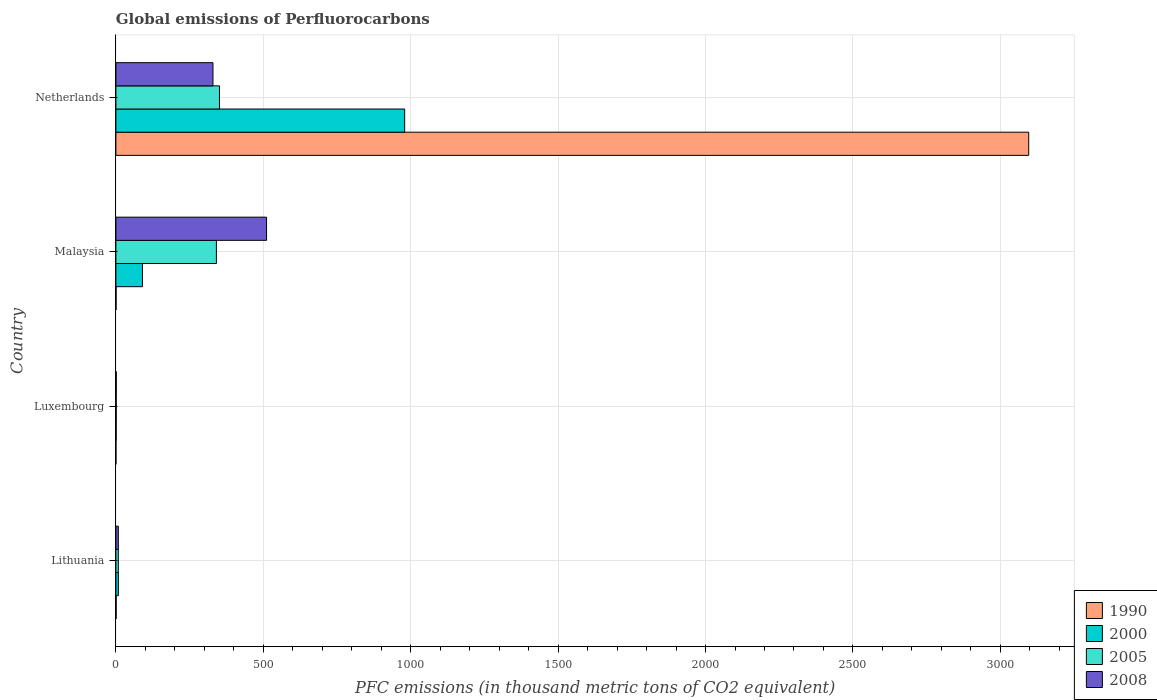How many different coloured bars are there?
Your answer should be very brief. 4. How many groups of bars are there?
Offer a terse response. 4. Are the number of bars on each tick of the Y-axis equal?
Your answer should be very brief. Yes. How many bars are there on the 2nd tick from the top?
Provide a short and direct response. 4. What is the label of the 1st group of bars from the top?
Your answer should be compact. Netherlands. Across all countries, what is the maximum global emissions of Perfluorocarbons in 2000?
Keep it short and to the point. 979.5. In which country was the global emissions of Perfluorocarbons in 2000 minimum?
Keep it short and to the point. Luxembourg. What is the total global emissions of Perfluorocarbons in 1990 in the graph?
Provide a short and direct response. 3097.8. What is the difference between the global emissions of Perfluorocarbons in 2008 in Lithuania and that in Malaysia?
Your answer should be compact. -502.8. What is the difference between the global emissions of Perfluorocarbons in 2000 in Malaysia and the global emissions of Perfluorocarbons in 2008 in Netherlands?
Keep it short and to the point. -239.1. What is the average global emissions of Perfluorocarbons in 2000 per country?
Your response must be concise. 269.75. What is the difference between the global emissions of Perfluorocarbons in 2008 and global emissions of Perfluorocarbons in 1990 in Malaysia?
Provide a short and direct response. 510.4. What is the ratio of the global emissions of Perfluorocarbons in 2008 in Lithuania to that in Malaysia?
Ensure brevity in your answer.  0.02. What is the difference between the highest and the second highest global emissions of Perfluorocarbons in 2000?
Your answer should be compact. 889.4. What is the difference between the highest and the lowest global emissions of Perfluorocarbons in 2000?
Keep it short and to the point. 978.5. In how many countries, is the global emissions of Perfluorocarbons in 2000 greater than the average global emissions of Perfluorocarbons in 2000 taken over all countries?
Ensure brevity in your answer.  1. Is the sum of the global emissions of Perfluorocarbons in 1990 in Lithuania and Malaysia greater than the maximum global emissions of Perfluorocarbons in 2008 across all countries?
Ensure brevity in your answer.  No. What does the 2nd bar from the top in Luxembourg represents?
Offer a very short reply. 2005. Is it the case that in every country, the sum of the global emissions of Perfluorocarbons in 2000 and global emissions of Perfluorocarbons in 1990 is greater than the global emissions of Perfluorocarbons in 2008?
Offer a very short reply. No. How many bars are there?
Provide a short and direct response. 16. Are all the bars in the graph horizontal?
Your response must be concise. Yes. How many countries are there in the graph?
Your answer should be very brief. 4. What is the difference between two consecutive major ticks on the X-axis?
Offer a very short reply. 500. Are the values on the major ticks of X-axis written in scientific E-notation?
Your response must be concise. No. Does the graph contain any zero values?
Your answer should be very brief. No. What is the title of the graph?
Provide a succinct answer. Global emissions of Perfluorocarbons. Does "1978" appear as one of the legend labels in the graph?
Your answer should be compact. No. What is the label or title of the X-axis?
Give a very brief answer. PFC emissions (in thousand metric tons of CO2 equivalent). What is the PFC emissions (in thousand metric tons of CO2 equivalent) of 1990 in Lithuania?
Offer a very short reply. 0.9. What is the PFC emissions (in thousand metric tons of CO2 equivalent) in 2005 in Lithuania?
Your answer should be very brief. 8.2. What is the PFC emissions (in thousand metric tons of CO2 equivalent) in 1990 in Luxembourg?
Offer a terse response. 0.1. What is the PFC emissions (in thousand metric tons of CO2 equivalent) in 2005 in Luxembourg?
Your answer should be very brief. 1.1. What is the PFC emissions (in thousand metric tons of CO2 equivalent) in 2008 in Luxembourg?
Your response must be concise. 1.2. What is the PFC emissions (in thousand metric tons of CO2 equivalent) in 1990 in Malaysia?
Provide a short and direct response. 0.6. What is the PFC emissions (in thousand metric tons of CO2 equivalent) in 2000 in Malaysia?
Keep it short and to the point. 90.1. What is the PFC emissions (in thousand metric tons of CO2 equivalent) of 2005 in Malaysia?
Keep it short and to the point. 340.9. What is the PFC emissions (in thousand metric tons of CO2 equivalent) in 2008 in Malaysia?
Ensure brevity in your answer.  511. What is the PFC emissions (in thousand metric tons of CO2 equivalent) of 1990 in Netherlands?
Provide a succinct answer. 3096.2. What is the PFC emissions (in thousand metric tons of CO2 equivalent) in 2000 in Netherlands?
Ensure brevity in your answer.  979.5. What is the PFC emissions (in thousand metric tons of CO2 equivalent) in 2005 in Netherlands?
Offer a very short reply. 351.4. What is the PFC emissions (in thousand metric tons of CO2 equivalent) in 2008 in Netherlands?
Provide a succinct answer. 329.2. Across all countries, what is the maximum PFC emissions (in thousand metric tons of CO2 equivalent) in 1990?
Your answer should be very brief. 3096.2. Across all countries, what is the maximum PFC emissions (in thousand metric tons of CO2 equivalent) in 2000?
Give a very brief answer. 979.5. Across all countries, what is the maximum PFC emissions (in thousand metric tons of CO2 equivalent) of 2005?
Your answer should be very brief. 351.4. Across all countries, what is the maximum PFC emissions (in thousand metric tons of CO2 equivalent) in 2008?
Offer a very short reply. 511. Across all countries, what is the minimum PFC emissions (in thousand metric tons of CO2 equivalent) of 2000?
Offer a very short reply. 1. What is the total PFC emissions (in thousand metric tons of CO2 equivalent) of 1990 in the graph?
Ensure brevity in your answer.  3097.8. What is the total PFC emissions (in thousand metric tons of CO2 equivalent) of 2000 in the graph?
Ensure brevity in your answer.  1079. What is the total PFC emissions (in thousand metric tons of CO2 equivalent) in 2005 in the graph?
Provide a succinct answer. 701.6. What is the total PFC emissions (in thousand metric tons of CO2 equivalent) in 2008 in the graph?
Your answer should be very brief. 849.6. What is the difference between the PFC emissions (in thousand metric tons of CO2 equivalent) in 2000 in Lithuania and that in Malaysia?
Your answer should be very brief. -81.7. What is the difference between the PFC emissions (in thousand metric tons of CO2 equivalent) in 2005 in Lithuania and that in Malaysia?
Give a very brief answer. -332.7. What is the difference between the PFC emissions (in thousand metric tons of CO2 equivalent) of 2008 in Lithuania and that in Malaysia?
Your response must be concise. -502.8. What is the difference between the PFC emissions (in thousand metric tons of CO2 equivalent) of 1990 in Lithuania and that in Netherlands?
Your answer should be compact. -3095.3. What is the difference between the PFC emissions (in thousand metric tons of CO2 equivalent) of 2000 in Lithuania and that in Netherlands?
Make the answer very short. -971.1. What is the difference between the PFC emissions (in thousand metric tons of CO2 equivalent) in 2005 in Lithuania and that in Netherlands?
Offer a very short reply. -343.2. What is the difference between the PFC emissions (in thousand metric tons of CO2 equivalent) in 2008 in Lithuania and that in Netherlands?
Your answer should be very brief. -321. What is the difference between the PFC emissions (in thousand metric tons of CO2 equivalent) in 1990 in Luxembourg and that in Malaysia?
Your response must be concise. -0.5. What is the difference between the PFC emissions (in thousand metric tons of CO2 equivalent) in 2000 in Luxembourg and that in Malaysia?
Give a very brief answer. -89.1. What is the difference between the PFC emissions (in thousand metric tons of CO2 equivalent) in 2005 in Luxembourg and that in Malaysia?
Make the answer very short. -339.8. What is the difference between the PFC emissions (in thousand metric tons of CO2 equivalent) in 2008 in Luxembourg and that in Malaysia?
Your answer should be very brief. -509.8. What is the difference between the PFC emissions (in thousand metric tons of CO2 equivalent) of 1990 in Luxembourg and that in Netherlands?
Give a very brief answer. -3096.1. What is the difference between the PFC emissions (in thousand metric tons of CO2 equivalent) of 2000 in Luxembourg and that in Netherlands?
Your answer should be compact. -978.5. What is the difference between the PFC emissions (in thousand metric tons of CO2 equivalent) in 2005 in Luxembourg and that in Netherlands?
Offer a very short reply. -350.3. What is the difference between the PFC emissions (in thousand metric tons of CO2 equivalent) in 2008 in Luxembourg and that in Netherlands?
Offer a very short reply. -328. What is the difference between the PFC emissions (in thousand metric tons of CO2 equivalent) in 1990 in Malaysia and that in Netherlands?
Your response must be concise. -3095.6. What is the difference between the PFC emissions (in thousand metric tons of CO2 equivalent) in 2000 in Malaysia and that in Netherlands?
Offer a very short reply. -889.4. What is the difference between the PFC emissions (in thousand metric tons of CO2 equivalent) of 2005 in Malaysia and that in Netherlands?
Your response must be concise. -10.5. What is the difference between the PFC emissions (in thousand metric tons of CO2 equivalent) in 2008 in Malaysia and that in Netherlands?
Your answer should be compact. 181.8. What is the difference between the PFC emissions (in thousand metric tons of CO2 equivalent) of 1990 in Lithuania and the PFC emissions (in thousand metric tons of CO2 equivalent) of 2000 in Luxembourg?
Provide a short and direct response. -0.1. What is the difference between the PFC emissions (in thousand metric tons of CO2 equivalent) in 1990 in Lithuania and the PFC emissions (in thousand metric tons of CO2 equivalent) in 2005 in Luxembourg?
Offer a terse response. -0.2. What is the difference between the PFC emissions (in thousand metric tons of CO2 equivalent) in 1990 in Lithuania and the PFC emissions (in thousand metric tons of CO2 equivalent) in 2008 in Luxembourg?
Your answer should be very brief. -0.3. What is the difference between the PFC emissions (in thousand metric tons of CO2 equivalent) of 2000 in Lithuania and the PFC emissions (in thousand metric tons of CO2 equivalent) of 2008 in Luxembourg?
Offer a very short reply. 7.2. What is the difference between the PFC emissions (in thousand metric tons of CO2 equivalent) in 2005 in Lithuania and the PFC emissions (in thousand metric tons of CO2 equivalent) in 2008 in Luxembourg?
Keep it short and to the point. 7. What is the difference between the PFC emissions (in thousand metric tons of CO2 equivalent) in 1990 in Lithuania and the PFC emissions (in thousand metric tons of CO2 equivalent) in 2000 in Malaysia?
Ensure brevity in your answer.  -89.2. What is the difference between the PFC emissions (in thousand metric tons of CO2 equivalent) of 1990 in Lithuania and the PFC emissions (in thousand metric tons of CO2 equivalent) of 2005 in Malaysia?
Ensure brevity in your answer.  -340. What is the difference between the PFC emissions (in thousand metric tons of CO2 equivalent) in 1990 in Lithuania and the PFC emissions (in thousand metric tons of CO2 equivalent) in 2008 in Malaysia?
Give a very brief answer. -510.1. What is the difference between the PFC emissions (in thousand metric tons of CO2 equivalent) of 2000 in Lithuania and the PFC emissions (in thousand metric tons of CO2 equivalent) of 2005 in Malaysia?
Keep it short and to the point. -332.5. What is the difference between the PFC emissions (in thousand metric tons of CO2 equivalent) in 2000 in Lithuania and the PFC emissions (in thousand metric tons of CO2 equivalent) in 2008 in Malaysia?
Your answer should be very brief. -502.6. What is the difference between the PFC emissions (in thousand metric tons of CO2 equivalent) of 2005 in Lithuania and the PFC emissions (in thousand metric tons of CO2 equivalent) of 2008 in Malaysia?
Give a very brief answer. -502.8. What is the difference between the PFC emissions (in thousand metric tons of CO2 equivalent) of 1990 in Lithuania and the PFC emissions (in thousand metric tons of CO2 equivalent) of 2000 in Netherlands?
Your response must be concise. -978.6. What is the difference between the PFC emissions (in thousand metric tons of CO2 equivalent) of 1990 in Lithuania and the PFC emissions (in thousand metric tons of CO2 equivalent) of 2005 in Netherlands?
Keep it short and to the point. -350.5. What is the difference between the PFC emissions (in thousand metric tons of CO2 equivalent) of 1990 in Lithuania and the PFC emissions (in thousand metric tons of CO2 equivalent) of 2008 in Netherlands?
Make the answer very short. -328.3. What is the difference between the PFC emissions (in thousand metric tons of CO2 equivalent) in 2000 in Lithuania and the PFC emissions (in thousand metric tons of CO2 equivalent) in 2005 in Netherlands?
Your answer should be very brief. -343. What is the difference between the PFC emissions (in thousand metric tons of CO2 equivalent) of 2000 in Lithuania and the PFC emissions (in thousand metric tons of CO2 equivalent) of 2008 in Netherlands?
Your answer should be compact. -320.8. What is the difference between the PFC emissions (in thousand metric tons of CO2 equivalent) in 2005 in Lithuania and the PFC emissions (in thousand metric tons of CO2 equivalent) in 2008 in Netherlands?
Provide a short and direct response. -321. What is the difference between the PFC emissions (in thousand metric tons of CO2 equivalent) of 1990 in Luxembourg and the PFC emissions (in thousand metric tons of CO2 equivalent) of 2000 in Malaysia?
Your response must be concise. -90. What is the difference between the PFC emissions (in thousand metric tons of CO2 equivalent) of 1990 in Luxembourg and the PFC emissions (in thousand metric tons of CO2 equivalent) of 2005 in Malaysia?
Make the answer very short. -340.8. What is the difference between the PFC emissions (in thousand metric tons of CO2 equivalent) of 1990 in Luxembourg and the PFC emissions (in thousand metric tons of CO2 equivalent) of 2008 in Malaysia?
Provide a succinct answer. -510.9. What is the difference between the PFC emissions (in thousand metric tons of CO2 equivalent) in 2000 in Luxembourg and the PFC emissions (in thousand metric tons of CO2 equivalent) in 2005 in Malaysia?
Keep it short and to the point. -339.9. What is the difference between the PFC emissions (in thousand metric tons of CO2 equivalent) of 2000 in Luxembourg and the PFC emissions (in thousand metric tons of CO2 equivalent) of 2008 in Malaysia?
Your answer should be very brief. -510. What is the difference between the PFC emissions (in thousand metric tons of CO2 equivalent) in 2005 in Luxembourg and the PFC emissions (in thousand metric tons of CO2 equivalent) in 2008 in Malaysia?
Ensure brevity in your answer.  -509.9. What is the difference between the PFC emissions (in thousand metric tons of CO2 equivalent) of 1990 in Luxembourg and the PFC emissions (in thousand metric tons of CO2 equivalent) of 2000 in Netherlands?
Your answer should be very brief. -979.4. What is the difference between the PFC emissions (in thousand metric tons of CO2 equivalent) in 1990 in Luxembourg and the PFC emissions (in thousand metric tons of CO2 equivalent) in 2005 in Netherlands?
Give a very brief answer. -351.3. What is the difference between the PFC emissions (in thousand metric tons of CO2 equivalent) of 1990 in Luxembourg and the PFC emissions (in thousand metric tons of CO2 equivalent) of 2008 in Netherlands?
Make the answer very short. -329.1. What is the difference between the PFC emissions (in thousand metric tons of CO2 equivalent) in 2000 in Luxembourg and the PFC emissions (in thousand metric tons of CO2 equivalent) in 2005 in Netherlands?
Provide a succinct answer. -350.4. What is the difference between the PFC emissions (in thousand metric tons of CO2 equivalent) of 2000 in Luxembourg and the PFC emissions (in thousand metric tons of CO2 equivalent) of 2008 in Netherlands?
Offer a very short reply. -328.2. What is the difference between the PFC emissions (in thousand metric tons of CO2 equivalent) in 2005 in Luxembourg and the PFC emissions (in thousand metric tons of CO2 equivalent) in 2008 in Netherlands?
Provide a short and direct response. -328.1. What is the difference between the PFC emissions (in thousand metric tons of CO2 equivalent) of 1990 in Malaysia and the PFC emissions (in thousand metric tons of CO2 equivalent) of 2000 in Netherlands?
Give a very brief answer. -978.9. What is the difference between the PFC emissions (in thousand metric tons of CO2 equivalent) of 1990 in Malaysia and the PFC emissions (in thousand metric tons of CO2 equivalent) of 2005 in Netherlands?
Your answer should be very brief. -350.8. What is the difference between the PFC emissions (in thousand metric tons of CO2 equivalent) of 1990 in Malaysia and the PFC emissions (in thousand metric tons of CO2 equivalent) of 2008 in Netherlands?
Give a very brief answer. -328.6. What is the difference between the PFC emissions (in thousand metric tons of CO2 equivalent) of 2000 in Malaysia and the PFC emissions (in thousand metric tons of CO2 equivalent) of 2005 in Netherlands?
Your answer should be compact. -261.3. What is the difference between the PFC emissions (in thousand metric tons of CO2 equivalent) of 2000 in Malaysia and the PFC emissions (in thousand metric tons of CO2 equivalent) of 2008 in Netherlands?
Keep it short and to the point. -239.1. What is the difference between the PFC emissions (in thousand metric tons of CO2 equivalent) of 2005 in Malaysia and the PFC emissions (in thousand metric tons of CO2 equivalent) of 2008 in Netherlands?
Your answer should be very brief. 11.7. What is the average PFC emissions (in thousand metric tons of CO2 equivalent) in 1990 per country?
Your answer should be very brief. 774.45. What is the average PFC emissions (in thousand metric tons of CO2 equivalent) of 2000 per country?
Offer a terse response. 269.75. What is the average PFC emissions (in thousand metric tons of CO2 equivalent) of 2005 per country?
Provide a short and direct response. 175.4. What is the average PFC emissions (in thousand metric tons of CO2 equivalent) of 2008 per country?
Provide a short and direct response. 212.4. What is the difference between the PFC emissions (in thousand metric tons of CO2 equivalent) of 1990 and PFC emissions (in thousand metric tons of CO2 equivalent) of 2000 in Lithuania?
Provide a succinct answer. -7.5. What is the difference between the PFC emissions (in thousand metric tons of CO2 equivalent) of 1990 and PFC emissions (in thousand metric tons of CO2 equivalent) of 2005 in Lithuania?
Give a very brief answer. -7.3. What is the difference between the PFC emissions (in thousand metric tons of CO2 equivalent) in 2000 and PFC emissions (in thousand metric tons of CO2 equivalent) in 2005 in Lithuania?
Make the answer very short. 0.2. What is the difference between the PFC emissions (in thousand metric tons of CO2 equivalent) in 1990 and PFC emissions (in thousand metric tons of CO2 equivalent) in 2000 in Luxembourg?
Offer a very short reply. -0.9. What is the difference between the PFC emissions (in thousand metric tons of CO2 equivalent) of 1990 and PFC emissions (in thousand metric tons of CO2 equivalent) of 2005 in Luxembourg?
Keep it short and to the point. -1. What is the difference between the PFC emissions (in thousand metric tons of CO2 equivalent) of 1990 and PFC emissions (in thousand metric tons of CO2 equivalent) of 2008 in Luxembourg?
Give a very brief answer. -1.1. What is the difference between the PFC emissions (in thousand metric tons of CO2 equivalent) in 2000 and PFC emissions (in thousand metric tons of CO2 equivalent) in 2005 in Luxembourg?
Make the answer very short. -0.1. What is the difference between the PFC emissions (in thousand metric tons of CO2 equivalent) in 2000 and PFC emissions (in thousand metric tons of CO2 equivalent) in 2008 in Luxembourg?
Give a very brief answer. -0.2. What is the difference between the PFC emissions (in thousand metric tons of CO2 equivalent) of 2005 and PFC emissions (in thousand metric tons of CO2 equivalent) of 2008 in Luxembourg?
Your response must be concise. -0.1. What is the difference between the PFC emissions (in thousand metric tons of CO2 equivalent) in 1990 and PFC emissions (in thousand metric tons of CO2 equivalent) in 2000 in Malaysia?
Provide a short and direct response. -89.5. What is the difference between the PFC emissions (in thousand metric tons of CO2 equivalent) of 1990 and PFC emissions (in thousand metric tons of CO2 equivalent) of 2005 in Malaysia?
Ensure brevity in your answer.  -340.3. What is the difference between the PFC emissions (in thousand metric tons of CO2 equivalent) in 1990 and PFC emissions (in thousand metric tons of CO2 equivalent) in 2008 in Malaysia?
Offer a terse response. -510.4. What is the difference between the PFC emissions (in thousand metric tons of CO2 equivalent) in 2000 and PFC emissions (in thousand metric tons of CO2 equivalent) in 2005 in Malaysia?
Provide a short and direct response. -250.8. What is the difference between the PFC emissions (in thousand metric tons of CO2 equivalent) of 2000 and PFC emissions (in thousand metric tons of CO2 equivalent) of 2008 in Malaysia?
Provide a succinct answer. -420.9. What is the difference between the PFC emissions (in thousand metric tons of CO2 equivalent) in 2005 and PFC emissions (in thousand metric tons of CO2 equivalent) in 2008 in Malaysia?
Provide a short and direct response. -170.1. What is the difference between the PFC emissions (in thousand metric tons of CO2 equivalent) in 1990 and PFC emissions (in thousand metric tons of CO2 equivalent) in 2000 in Netherlands?
Your answer should be very brief. 2116.7. What is the difference between the PFC emissions (in thousand metric tons of CO2 equivalent) in 1990 and PFC emissions (in thousand metric tons of CO2 equivalent) in 2005 in Netherlands?
Ensure brevity in your answer.  2744.8. What is the difference between the PFC emissions (in thousand metric tons of CO2 equivalent) of 1990 and PFC emissions (in thousand metric tons of CO2 equivalent) of 2008 in Netherlands?
Provide a succinct answer. 2767. What is the difference between the PFC emissions (in thousand metric tons of CO2 equivalent) in 2000 and PFC emissions (in thousand metric tons of CO2 equivalent) in 2005 in Netherlands?
Ensure brevity in your answer.  628.1. What is the difference between the PFC emissions (in thousand metric tons of CO2 equivalent) in 2000 and PFC emissions (in thousand metric tons of CO2 equivalent) in 2008 in Netherlands?
Keep it short and to the point. 650.3. What is the ratio of the PFC emissions (in thousand metric tons of CO2 equivalent) in 1990 in Lithuania to that in Luxembourg?
Offer a very short reply. 9. What is the ratio of the PFC emissions (in thousand metric tons of CO2 equivalent) in 2005 in Lithuania to that in Luxembourg?
Offer a terse response. 7.45. What is the ratio of the PFC emissions (in thousand metric tons of CO2 equivalent) in 2008 in Lithuania to that in Luxembourg?
Your answer should be very brief. 6.83. What is the ratio of the PFC emissions (in thousand metric tons of CO2 equivalent) of 1990 in Lithuania to that in Malaysia?
Your answer should be very brief. 1.5. What is the ratio of the PFC emissions (in thousand metric tons of CO2 equivalent) of 2000 in Lithuania to that in Malaysia?
Provide a short and direct response. 0.09. What is the ratio of the PFC emissions (in thousand metric tons of CO2 equivalent) of 2005 in Lithuania to that in Malaysia?
Make the answer very short. 0.02. What is the ratio of the PFC emissions (in thousand metric tons of CO2 equivalent) in 2008 in Lithuania to that in Malaysia?
Make the answer very short. 0.02. What is the ratio of the PFC emissions (in thousand metric tons of CO2 equivalent) of 2000 in Lithuania to that in Netherlands?
Ensure brevity in your answer.  0.01. What is the ratio of the PFC emissions (in thousand metric tons of CO2 equivalent) in 2005 in Lithuania to that in Netherlands?
Offer a terse response. 0.02. What is the ratio of the PFC emissions (in thousand metric tons of CO2 equivalent) in 2008 in Lithuania to that in Netherlands?
Keep it short and to the point. 0.02. What is the ratio of the PFC emissions (in thousand metric tons of CO2 equivalent) in 1990 in Luxembourg to that in Malaysia?
Give a very brief answer. 0.17. What is the ratio of the PFC emissions (in thousand metric tons of CO2 equivalent) in 2000 in Luxembourg to that in Malaysia?
Your response must be concise. 0.01. What is the ratio of the PFC emissions (in thousand metric tons of CO2 equivalent) of 2005 in Luxembourg to that in Malaysia?
Provide a succinct answer. 0. What is the ratio of the PFC emissions (in thousand metric tons of CO2 equivalent) in 2008 in Luxembourg to that in Malaysia?
Provide a succinct answer. 0. What is the ratio of the PFC emissions (in thousand metric tons of CO2 equivalent) of 1990 in Luxembourg to that in Netherlands?
Give a very brief answer. 0. What is the ratio of the PFC emissions (in thousand metric tons of CO2 equivalent) of 2000 in Luxembourg to that in Netherlands?
Your answer should be very brief. 0. What is the ratio of the PFC emissions (in thousand metric tons of CO2 equivalent) of 2005 in Luxembourg to that in Netherlands?
Offer a very short reply. 0. What is the ratio of the PFC emissions (in thousand metric tons of CO2 equivalent) of 2008 in Luxembourg to that in Netherlands?
Make the answer very short. 0. What is the ratio of the PFC emissions (in thousand metric tons of CO2 equivalent) in 2000 in Malaysia to that in Netherlands?
Ensure brevity in your answer.  0.09. What is the ratio of the PFC emissions (in thousand metric tons of CO2 equivalent) of 2005 in Malaysia to that in Netherlands?
Keep it short and to the point. 0.97. What is the ratio of the PFC emissions (in thousand metric tons of CO2 equivalent) in 2008 in Malaysia to that in Netherlands?
Your response must be concise. 1.55. What is the difference between the highest and the second highest PFC emissions (in thousand metric tons of CO2 equivalent) of 1990?
Offer a terse response. 3095.3. What is the difference between the highest and the second highest PFC emissions (in thousand metric tons of CO2 equivalent) of 2000?
Ensure brevity in your answer.  889.4. What is the difference between the highest and the second highest PFC emissions (in thousand metric tons of CO2 equivalent) in 2005?
Offer a very short reply. 10.5. What is the difference between the highest and the second highest PFC emissions (in thousand metric tons of CO2 equivalent) in 2008?
Provide a short and direct response. 181.8. What is the difference between the highest and the lowest PFC emissions (in thousand metric tons of CO2 equivalent) in 1990?
Keep it short and to the point. 3096.1. What is the difference between the highest and the lowest PFC emissions (in thousand metric tons of CO2 equivalent) in 2000?
Offer a terse response. 978.5. What is the difference between the highest and the lowest PFC emissions (in thousand metric tons of CO2 equivalent) in 2005?
Provide a short and direct response. 350.3. What is the difference between the highest and the lowest PFC emissions (in thousand metric tons of CO2 equivalent) of 2008?
Provide a succinct answer. 509.8. 